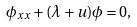<formula> <loc_0><loc_0><loc_500><loc_500>\phi _ { x x } + ( \lambda + u ) \phi = 0 ,</formula> 